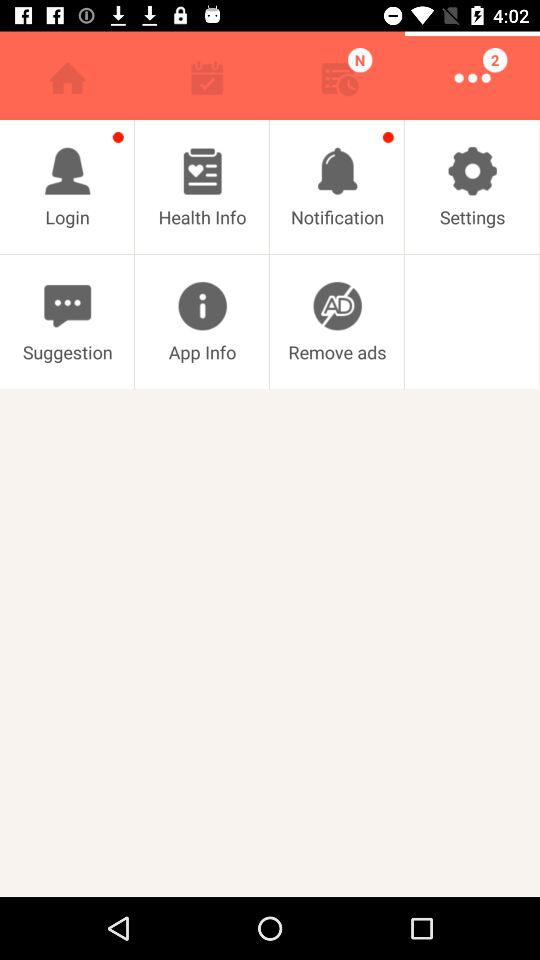How many unread notifications are there? There are 2 unread notifications. 